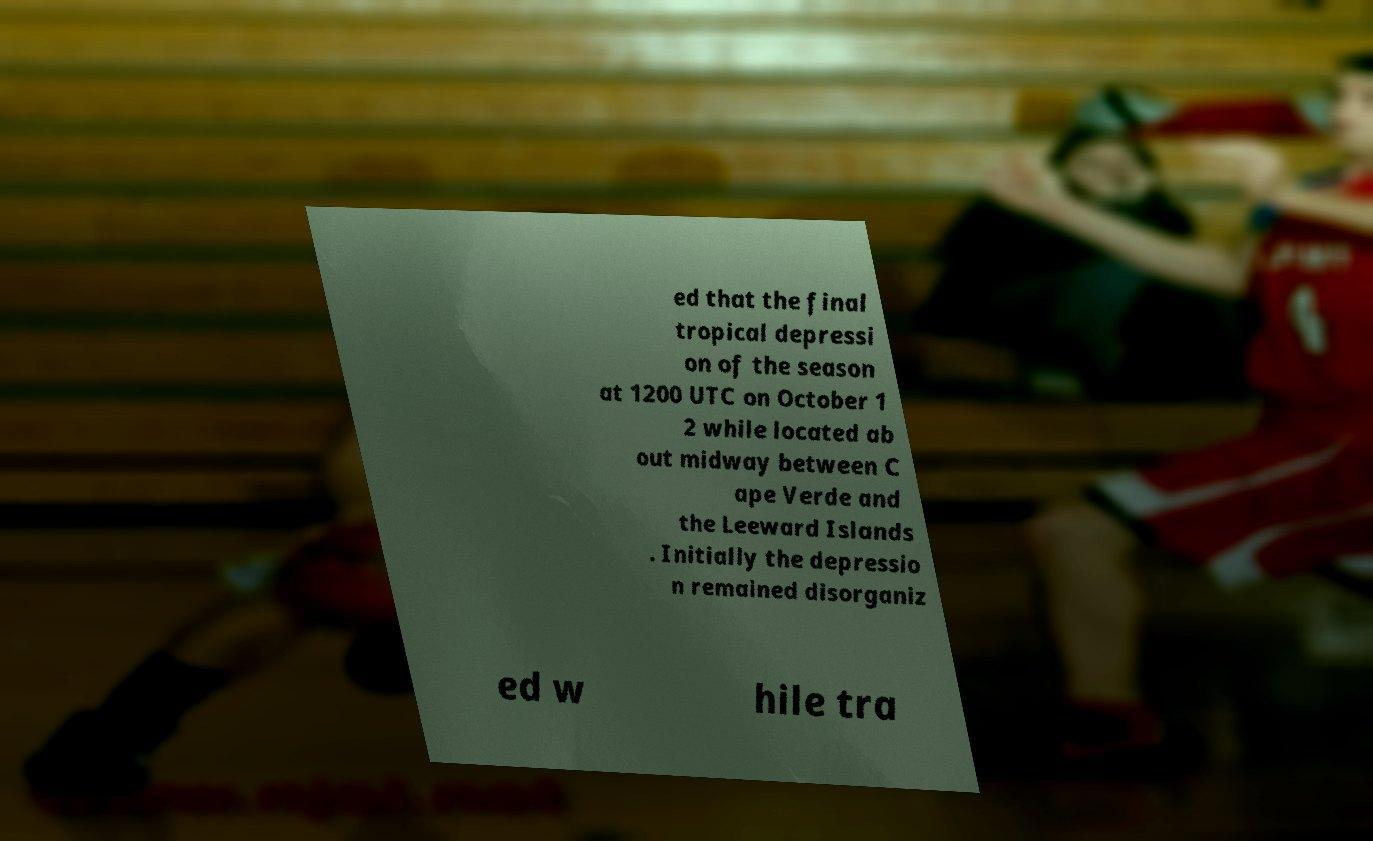Can you read and provide the text displayed in the image?This photo seems to have some interesting text. Can you extract and type it out for me? ed that the final tropical depressi on of the season at 1200 UTC on October 1 2 while located ab out midway between C ape Verde and the Leeward Islands . Initially the depressio n remained disorganiz ed w hile tra 